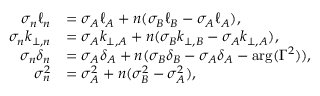Convert formula to latex. <formula><loc_0><loc_0><loc_500><loc_500>\begin{array} { r l } { \sigma _ { n } \ell _ { n } } & { = \sigma _ { A } \ell _ { A } + n ( \sigma _ { B } \ell _ { B } - \sigma _ { A } \ell _ { A } ) , } \\ { \sigma _ { n } k _ { \perp , n } } & { = \sigma _ { A } k _ { \perp , A } + n ( \sigma _ { B } k _ { \perp , B } - \sigma _ { A } k _ { \perp , A } ) , } \\ { \sigma _ { n } \delta _ { n } } & { = \sigma _ { A } \delta _ { A } + n ( \sigma _ { B } \delta _ { B } - \sigma _ { A } \delta _ { A } - \arg ( \Gamma ^ { 2 } ) ) , } \\ { \sigma _ { n } ^ { 2 } } & { = \sigma _ { A } ^ { 2 } + n ( \sigma _ { B } ^ { 2 } - \sigma _ { A } ^ { 2 } ) , } \end{array}</formula> 